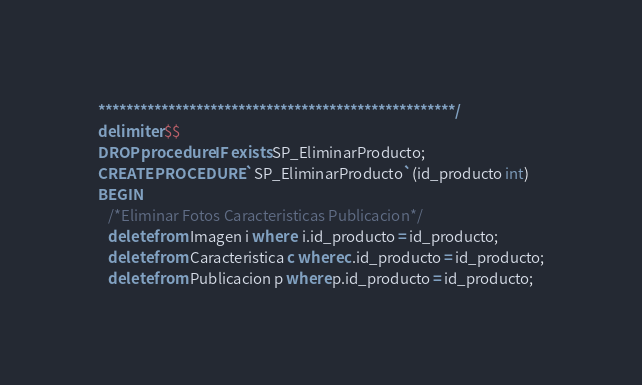Convert code to text. <code><loc_0><loc_0><loc_500><loc_500><_SQL_>***************************************************/
delimiter $$
DROP procedure IF exists SP_EliminarProducto;
CREATE PROCEDURE `SP_EliminarProducto`(id_producto int)
BEGIN
   /*Eliminar Fotos Caracteristicas Publicacion*/
   delete from Imagen i where  i.id_producto = id_producto;
   delete from Caracteristica c where c.id_producto = id_producto;
   delete from Publicacion p where p.id_producto = id_producto;</code> 